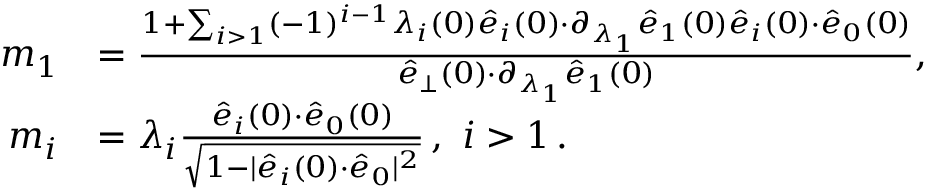Convert formula to latex. <formula><loc_0><loc_0><loc_500><loc_500>\begin{array} { r l } { \, m _ { 1 } } & { = \frac { 1 + \sum _ { i > 1 } ( - 1 ) ^ { i - 1 } \lambda _ { i } ( 0 ) \hat { e } _ { i } ( 0 ) { \cdot } \partial _ { \lambda _ { 1 } } \hat { e } _ { 1 } ( 0 ) \hat { e } _ { i } ( 0 ) { \cdot } \hat { e } _ { 0 } ( 0 ) } { \hat { e } _ { \perp } ( 0 ) { \cdot } \partial _ { \lambda _ { 1 } } \hat { e } _ { 1 } ( 0 ) } , } \\ { \, m _ { i } } & { = \lambda _ { i } \frac { \hat { e } _ { i } ( 0 ) { \cdot } \hat { e } _ { 0 } ( 0 ) } { \sqrt { 1 - | \hat { e } _ { i } ( 0 ) { \cdot } \hat { e } _ { 0 } | ^ { 2 } } } \, , i > 1 \, . } \end{array}</formula> 